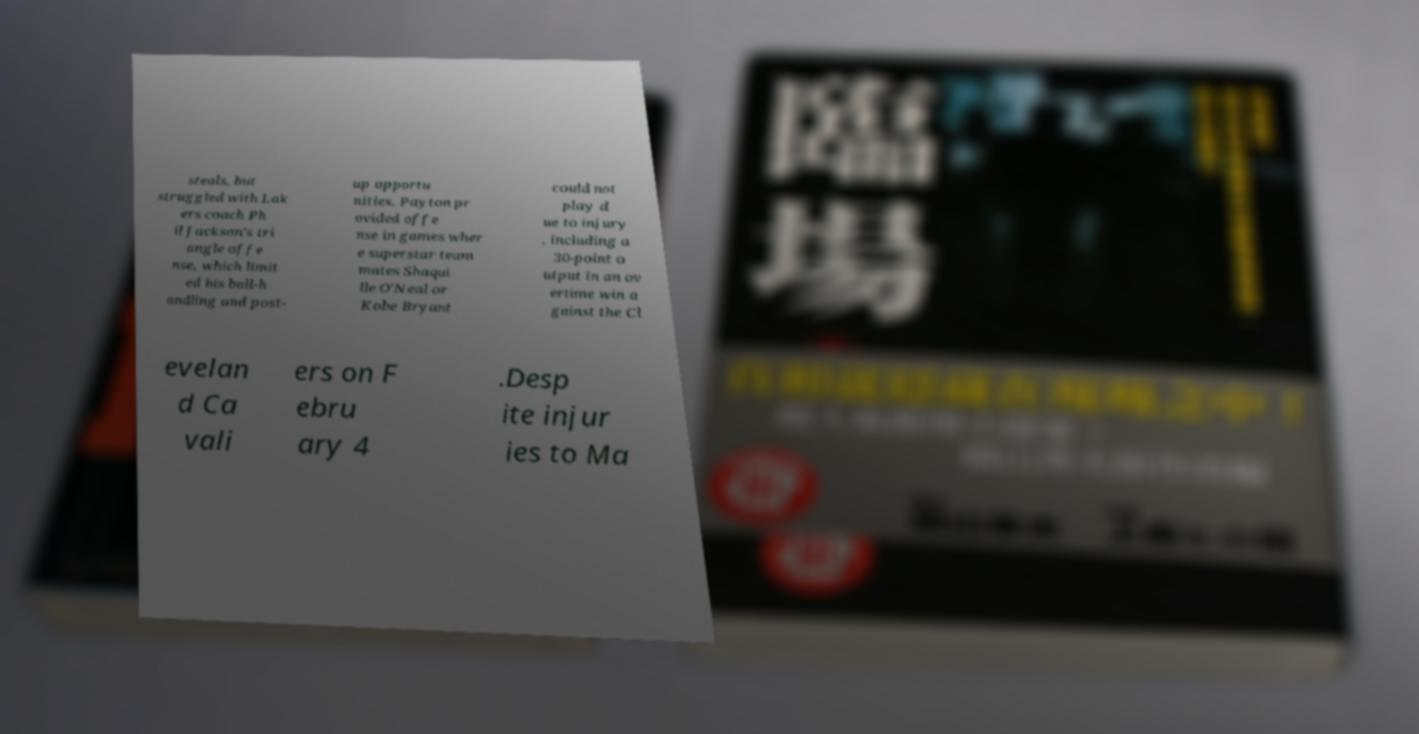For documentation purposes, I need the text within this image transcribed. Could you provide that? steals, but struggled with Lak ers coach Ph il Jackson's tri angle offe nse, which limit ed his ball-h andling and post- up opportu nities. Payton pr ovided offe nse in games wher e superstar team mates Shaqui lle O'Neal or Kobe Bryant could not play d ue to injury , including a 30-point o utput in an ov ertime win a gainst the Cl evelan d Ca vali ers on F ebru ary 4 .Desp ite injur ies to Ma 